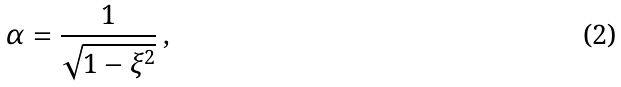Convert formula to latex. <formula><loc_0><loc_0><loc_500><loc_500>\alpha = \frac { 1 } { \sqrt { 1 - \xi ^ { 2 } } } \, ,</formula> 